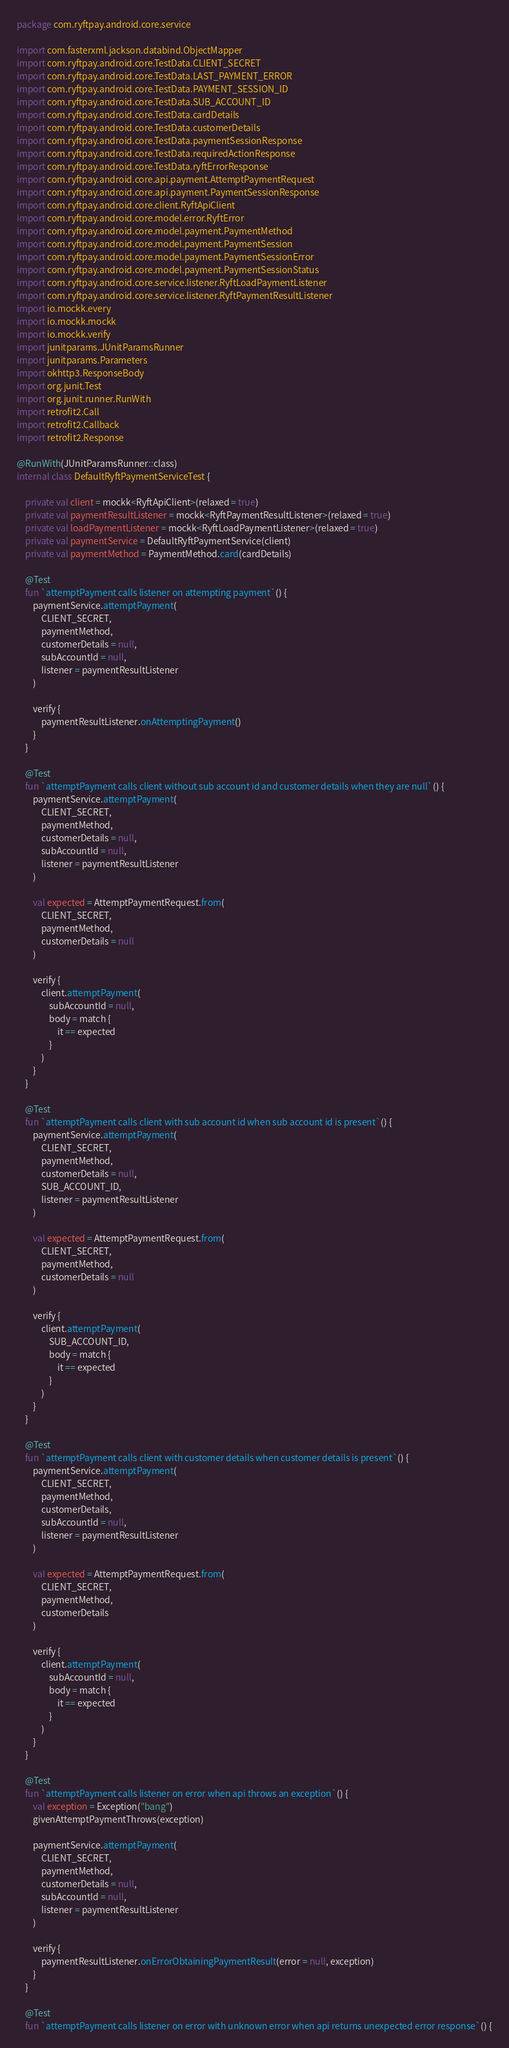Convert code to text. <code><loc_0><loc_0><loc_500><loc_500><_Kotlin_>package com.ryftpay.android.core.service

import com.fasterxml.jackson.databind.ObjectMapper
import com.ryftpay.android.core.TestData.CLIENT_SECRET
import com.ryftpay.android.core.TestData.LAST_PAYMENT_ERROR
import com.ryftpay.android.core.TestData.PAYMENT_SESSION_ID
import com.ryftpay.android.core.TestData.SUB_ACCOUNT_ID
import com.ryftpay.android.core.TestData.cardDetails
import com.ryftpay.android.core.TestData.customerDetails
import com.ryftpay.android.core.TestData.paymentSessionResponse
import com.ryftpay.android.core.TestData.requiredActionResponse
import com.ryftpay.android.core.TestData.ryftErrorResponse
import com.ryftpay.android.core.api.payment.AttemptPaymentRequest
import com.ryftpay.android.core.api.payment.PaymentSessionResponse
import com.ryftpay.android.core.client.RyftApiClient
import com.ryftpay.android.core.model.error.RyftError
import com.ryftpay.android.core.model.payment.PaymentMethod
import com.ryftpay.android.core.model.payment.PaymentSession
import com.ryftpay.android.core.model.payment.PaymentSessionError
import com.ryftpay.android.core.model.payment.PaymentSessionStatus
import com.ryftpay.android.core.service.listener.RyftLoadPaymentListener
import com.ryftpay.android.core.service.listener.RyftPaymentResultListener
import io.mockk.every
import io.mockk.mockk
import io.mockk.verify
import junitparams.JUnitParamsRunner
import junitparams.Parameters
import okhttp3.ResponseBody
import org.junit.Test
import org.junit.runner.RunWith
import retrofit2.Call
import retrofit2.Callback
import retrofit2.Response

@RunWith(JUnitParamsRunner::class)
internal class DefaultRyftPaymentServiceTest {

    private val client = mockk<RyftApiClient>(relaxed = true)
    private val paymentResultListener = mockk<RyftPaymentResultListener>(relaxed = true)
    private val loadPaymentListener = mockk<RyftLoadPaymentListener>(relaxed = true)
    private val paymentService = DefaultRyftPaymentService(client)
    private val paymentMethod = PaymentMethod.card(cardDetails)

    @Test
    fun `attemptPayment calls listener on attempting payment`() {
        paymentService.attemptPayment(
            CLIENT_SECRET,
            paymentMethod,
            customerDetails = null,
            subAccountId = null,
            listener = paymentResultListener
        )

        verify {
            paymentResultListener.onAttemptingPayment()
        }
    }

    @Test
    fun `attemptPayment calls client without sub account id and customer details when they are null`() {
        paymentService.attemptPayment(
            CLIENT_SECRET,
            paymentMethod,
            customerDetails = null,
            subAccountId = null,
            listener = paymentResultListener
        )

        val expected = AttemptPaymentRequest.from(
            CLIENT_SECRET,
            paymentMethod,
            customerDetails = null
        )

        verify {
            client.attemptPayment(
                subAccountId = null,
                body = match {
                    it == expected
                }
            )
        }
    }

    @Test
    fun `attemptPayment calls client with sub account id when sub account id is present`() {
        paymentService.attemptPayment(
            CLIENT_SECRET,
            paymentMethod,
            customerDetails = null,
            SUB_ACCOUNT_ID,
            listener = paymentResultListener
        )

        val expected = AttemptPaymentRequest.from(
            CLIENT_SECRET,
            paymentMethod,
            customerDetails = null
        )

        verify {
            client.attemptPayment(
                SUB_ACCOUNT_ID,
                body = match {
                    it == expected
                }
            )
        }
    }

    @Test
    fun `attemptPayment calls client with customer details when customer details is present`() {
        paymentService.attemptPayment(
            CLIENT_SECRET,
            paymentMethod,
            customerDetails,
            subAccountId = null,
            listener = paymentResultListener
        )

        val expected = AttemptPaymentRequest.from(
            CLIENT_SECRET,
            paymentMethod,
            customerDetails
        )

        verify {
            client.attemptPayment(
                subAccountId = null,
                body = match {
                    it == expected
                }
            )
        }
    }

    @Test
    fun `attemptPayment calls listener on error when api throws an exception`() {
        val exception = Exception("bang")
        givenAttemptPaymentThrows(exception)

        paymentService.attemptPayment(
            CLIENT_SECRET,
            paymentMethod,
            customerDetails = null,
            subAccountId = null,
            listener = paymentResultListener
        )

        verify {
            paymentResultListener.onErrorObtainingPaymentResult(error = null, exception)
        }
    }

    @Test
    fun `attemptPayment calls listener on error with unknown error when api returns unexpected error response`() {</code> 